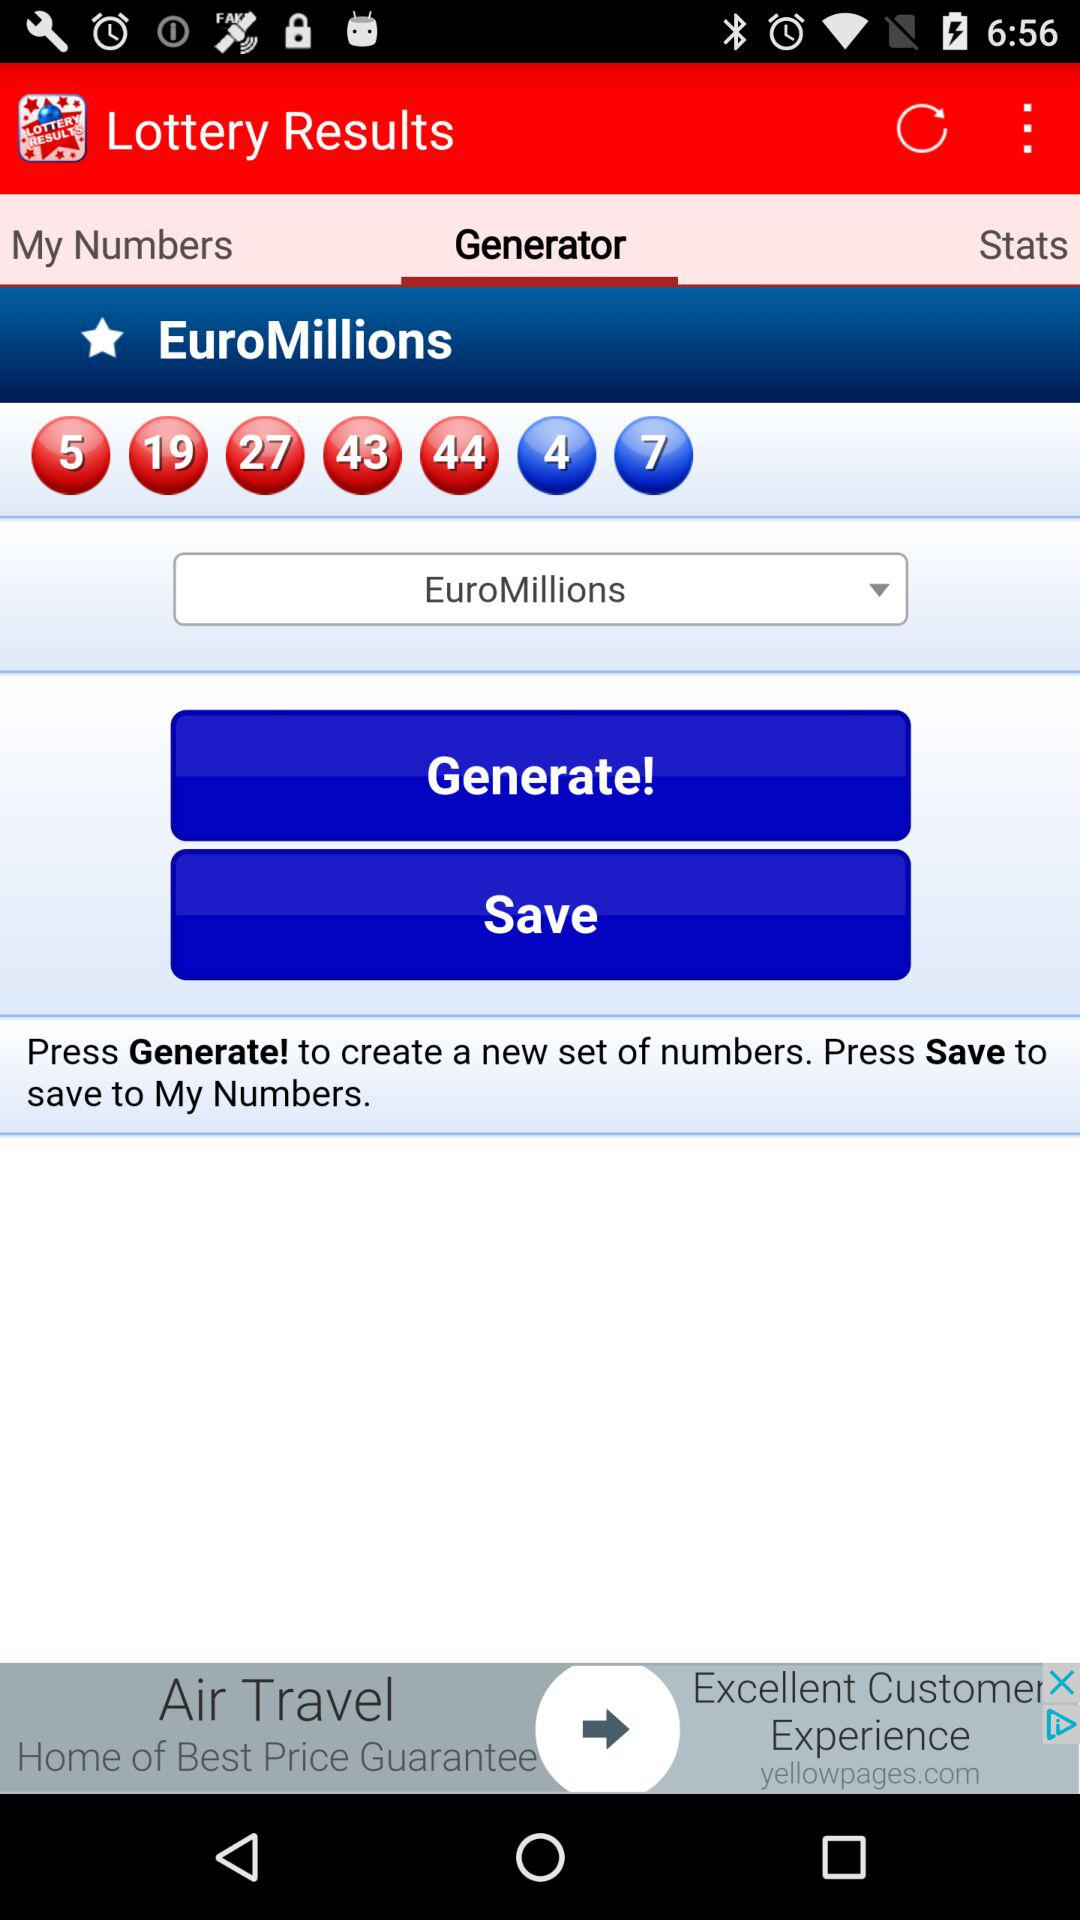What is the type of lottery numbers given? The lottery type is "EuroMillions". 